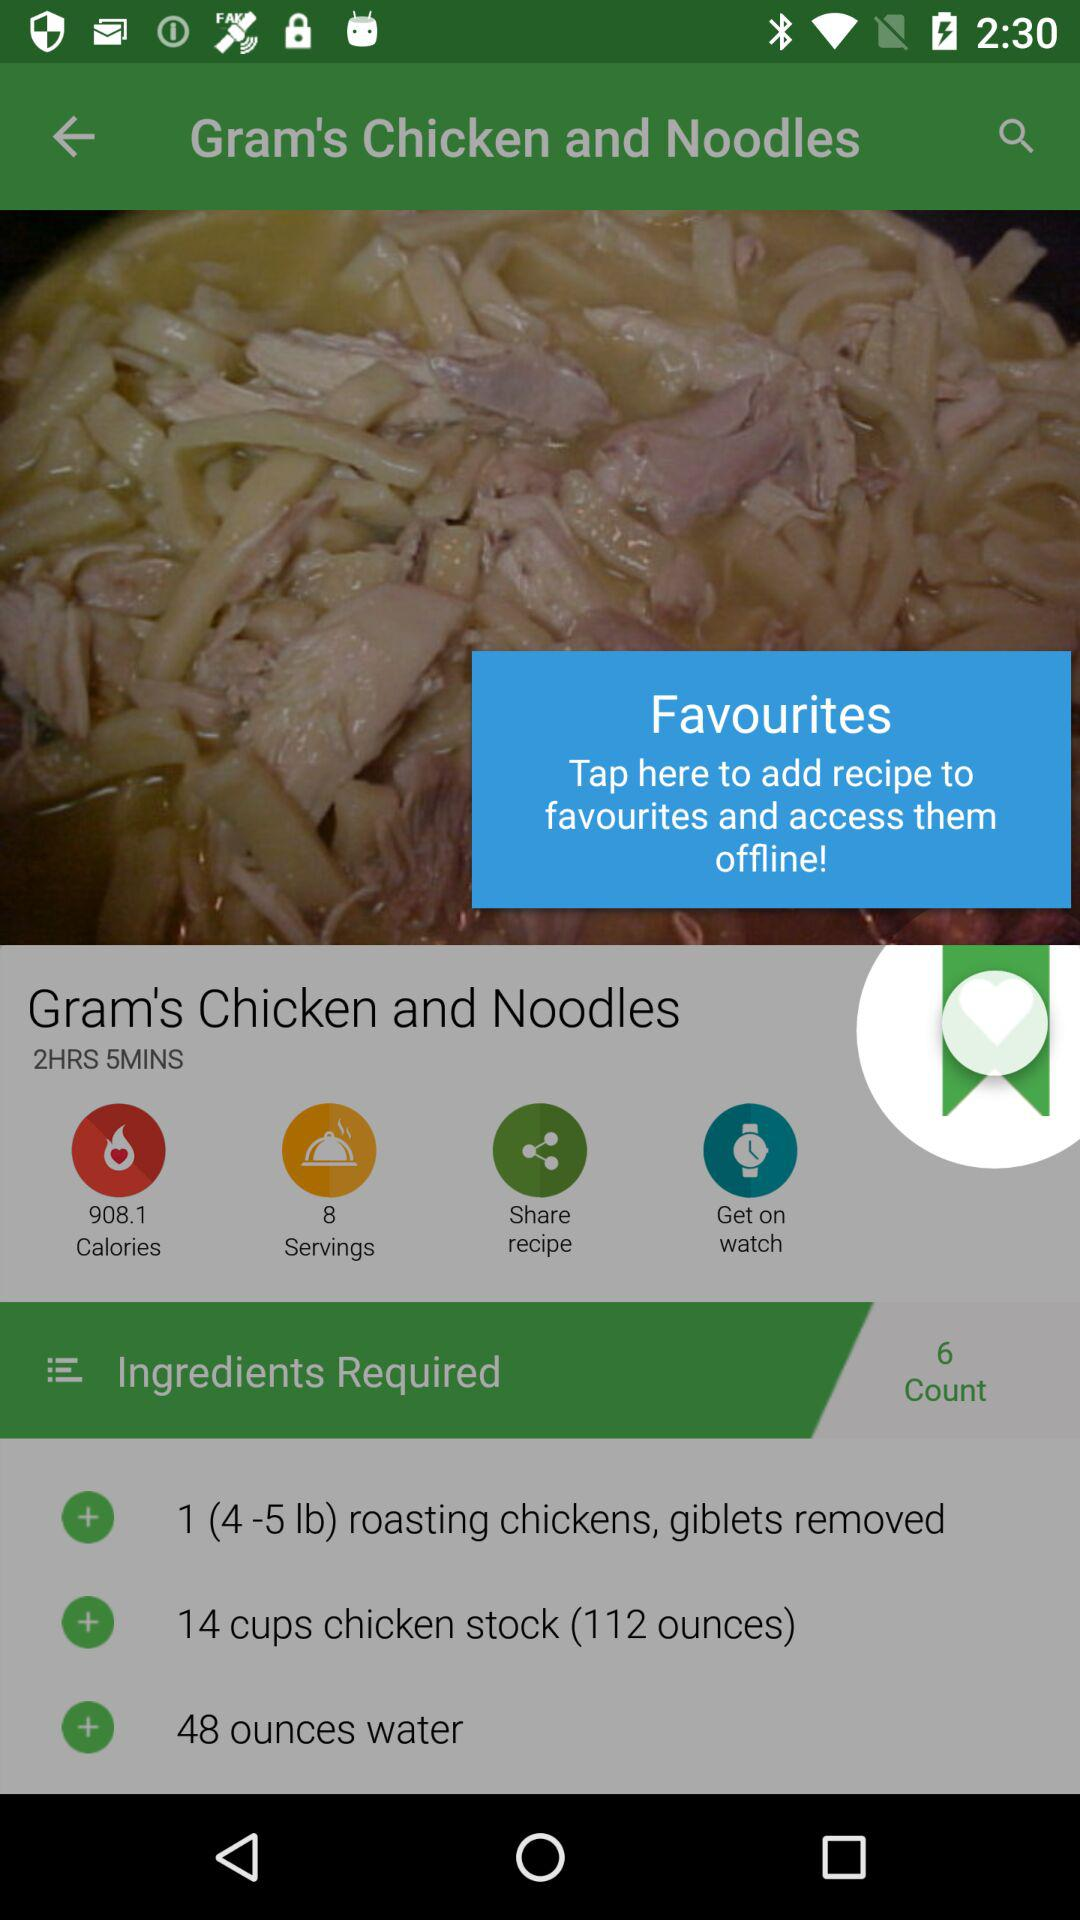What is the name of the recipe? The name of the recipe is "Gram's Chicken and Noodles". 